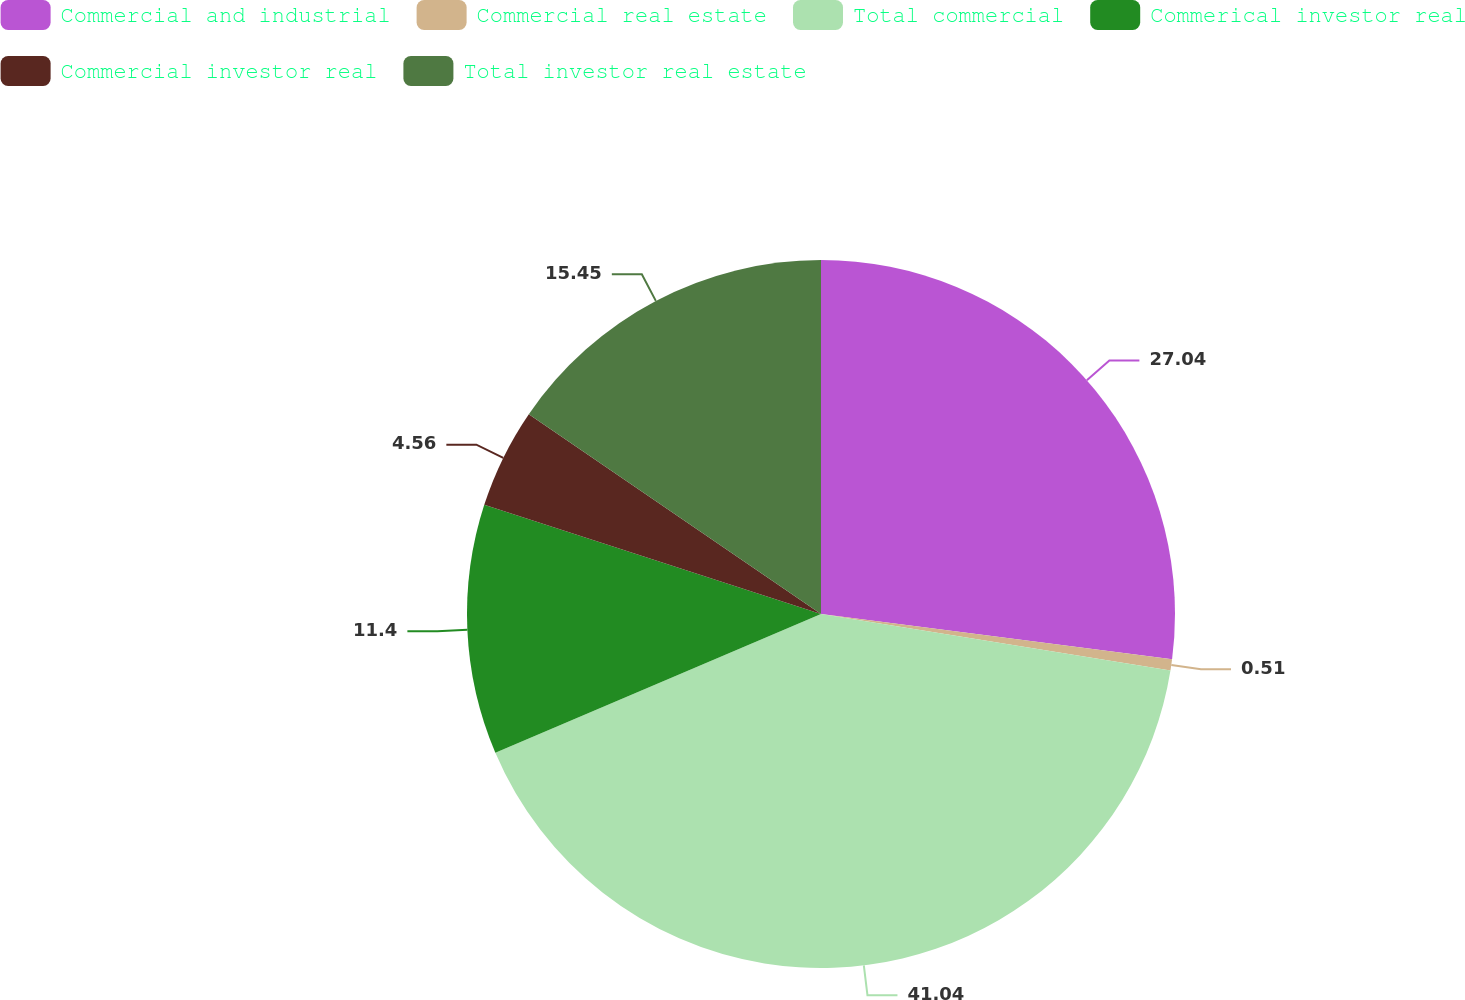<chart> <loc_0><loc_0><loc_500><loc_500><pie_chart><fcel>Commercial and industrial<fcel>Commercial real estate<fcel>Total commercial<fcel>Commerical investor real<fcel>Commercial investor real<fcel>Total investor real estate<nl><fcel>27.04%<fcel>0.51%<fcel>41.03%<fcel>11.4%<fcel>4.56%<fcel>15.45%<nl></chart> 